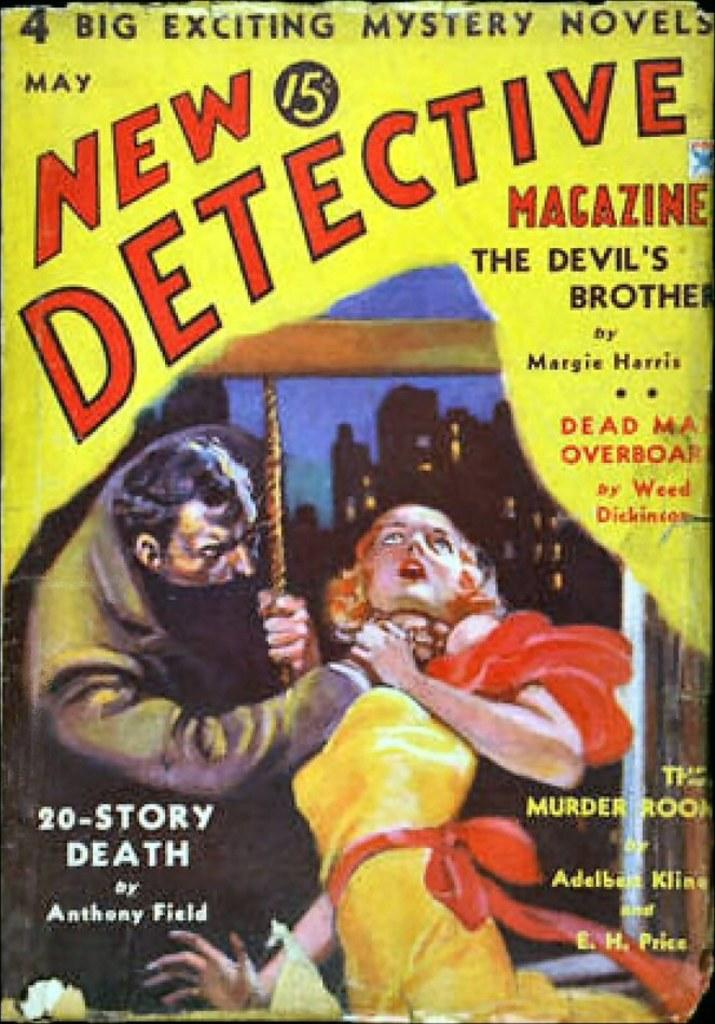What type of visual is the image in question? The image is a poster. What can be seen on the poster? There is an image of two persons on the poster, as well as buildings, the sky, and words and numbers. Can you describe the people depicted on the poster? Unfortunately, the facts provided do not give specific details about the people on the poster. What is the background of the poster? The background of the poster includes buildings and the sky. What type of locket is the woman wearing in the image? There is no woman wearing a locket in the image, as the facts provided do not mention any jewelry or accessories. How does the image reflect the theme of summer? The facts provided do not mention any seasonal or weather-related details, so it is impossible to determine if the image reflects the theme of summer. 